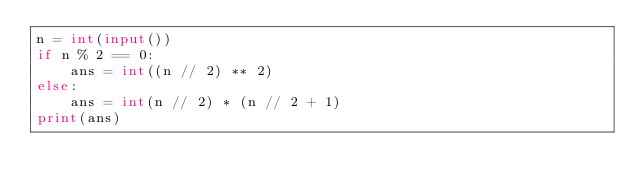Convert code to text. <code><loc_0><loc_0><loc_500><loc_500><_Python_>n = int(input())
if n % 2 == 0:
    ans = int((n // 2) ** 2)
else:
    ans = int(n // 2) * (n // 2 + 1)
print(ans)</code> 